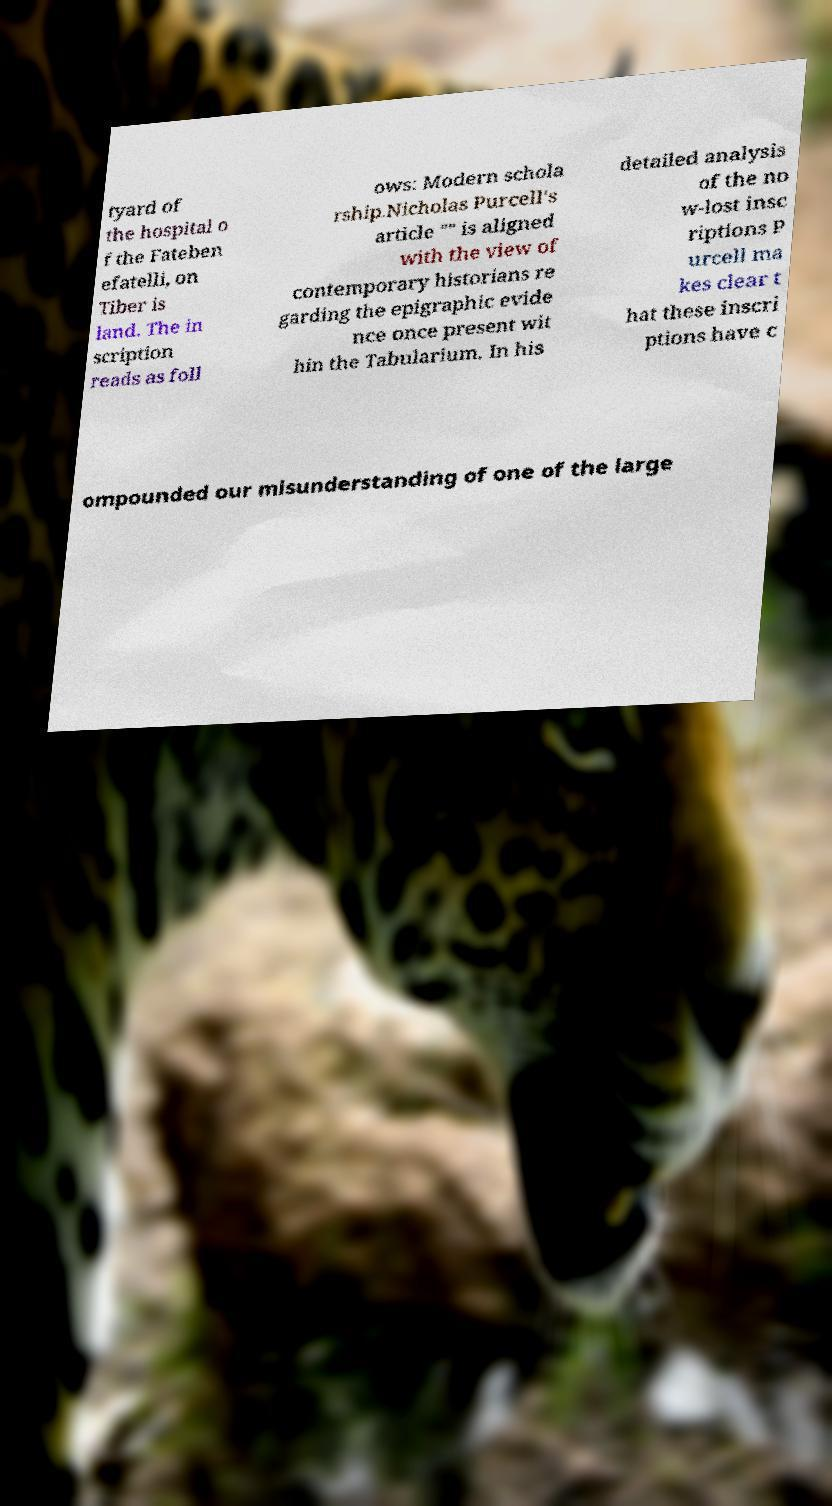Can you accurately transcribe the text from the provided image for me? tyard of the hospital o f the Fateben efatelli, on Tiber is land. The in scription reads as foll ows: Modern schola rship.Nicholas Purcell's article "" is aligned with the view of contemporary historians re garding the epigraphic evide nce once present wit hin the Tabularium. In his detailed analysis of the no w-lost insc riptions P urcell ma kes clear t hat these inscri ptions have c ompounded our misunderstanding of one of the large 